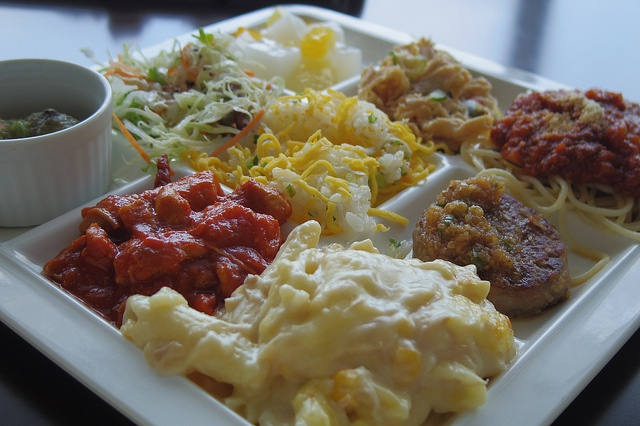Describe the objects in this image and their specific colors. I can see dining table in black, lightblue, lavender, and darkgray tones, bowl in black, gray, darkgreen, and lightblue tones, carrot in black, maroon, brown, and gray tones, carrot in black, darkgray, tan, and olive tones, and carrot in black and olive tones in this image. 